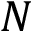Convert formula to latex. <formula><loc_0><loc_0><loc_500><loc_500>N</formula> 